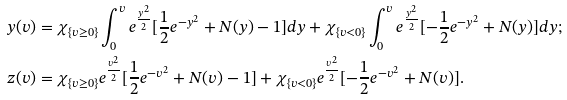Convert formula to latex. <formula><loc_0><loc_0><loc_500><loc_500>y ( v ) & = \chi _ { \{ v \geq 0 \} } \int _ { 0 } ^ { v } e ^ { \frac { y ^ { 2 } } { 2 } } [ \frac { 1 } { 2 } e ^ { - y ^ { 2 } } + N ( y ) - 1 ] d y + \chi _ { \{ v < 0 \} } \int _ { 0 } ^ { v } e ^ { \frac { y ^ { 2 } } { 2 } } [ - \frac { 1 } { 2 } e ^ { - y ^ { 2 } } + N ( y ) ] d y ; \\ z ( v ) & = \chi _ { \{ v \geq 0 \} } e ^ { \frac { v ^ { 2 } } { 2 } } [ \frac { 1 } { 2 } e ^ { - v ^ { 2 } } + N ( v ) - 1 ] + \chi _ { \{ v < 0 \} } e ^ { \frac { v ^ { 2 } } { 2 } } [ - \frac { 1 } { 2 } e ^ { - v ^ { 2 } } + N ( v ) ] .</formula> 